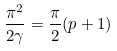Convert formula to latex. <formula><loc_0><loc_0><loc_500><loc_500>\frac { \pi ^ { 2 } } { 2 \gamma } = \frac { \pi } { 2 } ( p + 1 )</formula> 